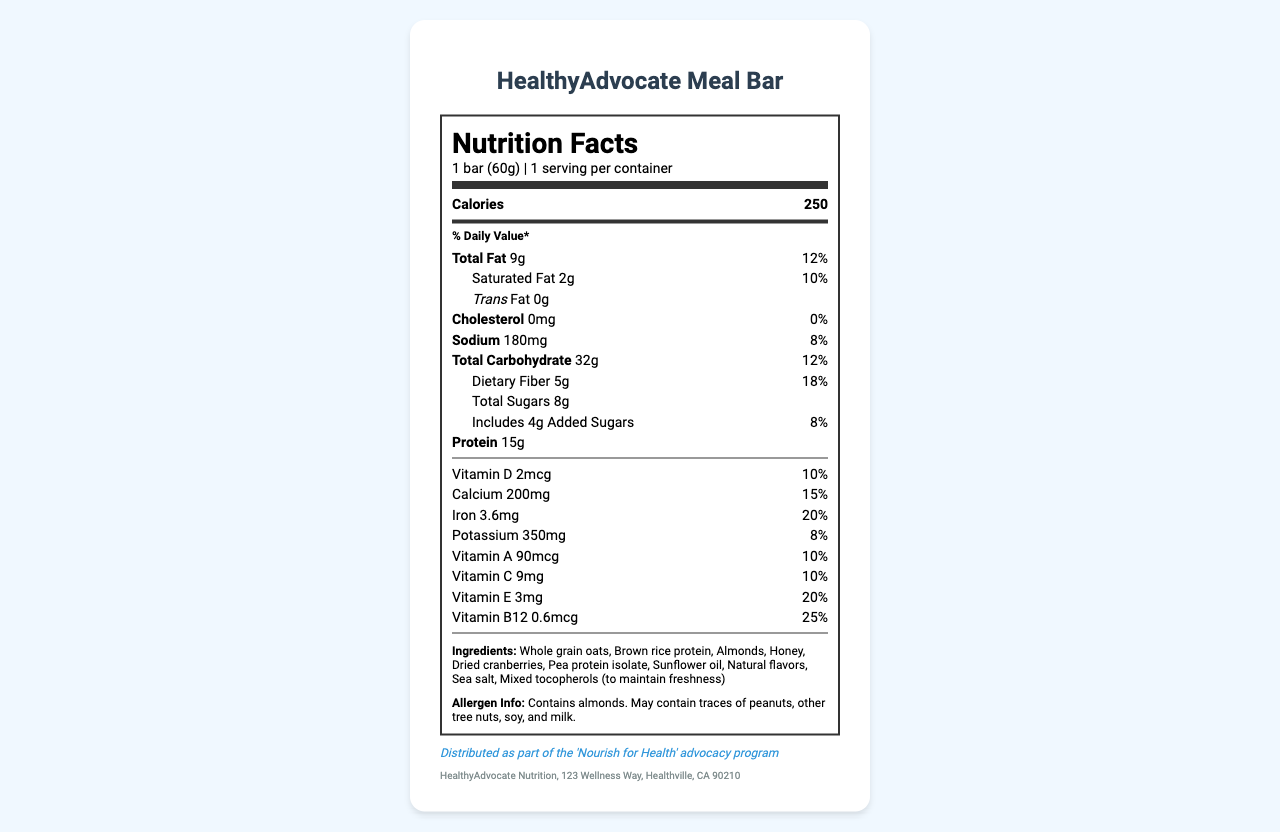what is the serving size? The serving size is mentioned as "1 bar (60g)" under the nutrition header of the document.
Answer: 1 bar (60g) how many calories are in one serving? The document specifies that there are 250 calories per serving in the "Calories" section.
Answer: 250 what percentage of daily value is provided by the total fat in the bar? The document shows that the total fat content is 9g, which corresponds to 12% of the daily value.
Answer: 12% do these bars contain any trans fat? The document states that there are 0g of trans fat in these bars.
Answer: No which ingredient contributes to the protein content of the bar? The ingredients list mentions "Brown rice protein" and "Pea protein isolate," both known sources of protein.
Answer: Brown rice protein, Pea protein isolate what is the amount of dietary fiber per serving? The document shows that each serving contains 5g of dietary fiber.
Answer: 5g what vitamins are included in this meal bar? The vitamins section lists these specific vitamins and minerals.
Answer: Vitamin D, Calcium, Iron, Potassium, Vitamin A, Vitamin C, Vitamin E, Vitamin B12 which of the following is an ingredient of the HealthyAdvocate Meal Bar? A. Soy protein B. Sunflower oil C. Artificial flavors The ingredient list shows "Sunflower oil," while the other two options are not listed.
Answer: B what is the daily value percentage for vitamin B12? A. 10% B. 20% C. 25% D. 30% The document states that the daily value for Vitamin B12 is 25%.
Answer: C does this product contain any allergens? The allergen information section specifies that the product contains almonds and may contain traces of peanuts, other tree nuts, soy, and milk.
Answer: Yes is this meal bar suitable for someone with a peanut allergy? The allergen info indicates that it contains almonds and may have traces of peanuts, making it unsuitable for someone with a peanut allergy.
Answer: No summarize the main focus of this document. The document comprehensively lists the nutritional facts, ingredients, allergens, and campaign information for the meal bar.
Answer: This document provides the nutritional information and ingredients for the HealthyAdvocate Meal Bar, including details about serving size, calories, fats, carbohydrates, proteins, vitamins, and potential allergens. It also highlights that the bar is distributed as part of the 'Nourish for Health' advocacy program by HealthyAdvocate Nutrition. what is the contact address of the manufacturer? This information is located at the bottom of the document under manufacturer contact details.
Answer: HealthyAdvocate Nutrition, 123 Wellness Way, Healthville, CA 90210 what type of fat is completely absent from the bar? The nutrition information clearly states that the trans fat content is 0g, indicating its absence.
Answer: Trans Fat how much added sugar is in one serving? The amount of added sugars is specified as 4g in the document.
Answer: 4g is this product included in any special program? The campaign info section mentions that the meal bar is part of the 'Nourish for Health' advocacy program.
Answer: Yes sodium contributes to what percentage of the daily value? The document details that the sodium content is 180mg, which is 8% of the daily value.
Answer: 8% why is sea salt included in the ingredients? The document lists sea salt as an ingredient but does not provide a specific reason for its inclusion.
Answer: Not enough information what is the total carbohydrate content per serving? Under the carbohydrate section, the document states that there are 32g of total carbohydrates per serving.
Answer: 32g which vitamin has the highest daily value percentage? The daily value percentage for Vitamin B12 is listed as 25%, the highest among the vitamins in the document.
Answer: Vitamin B12 